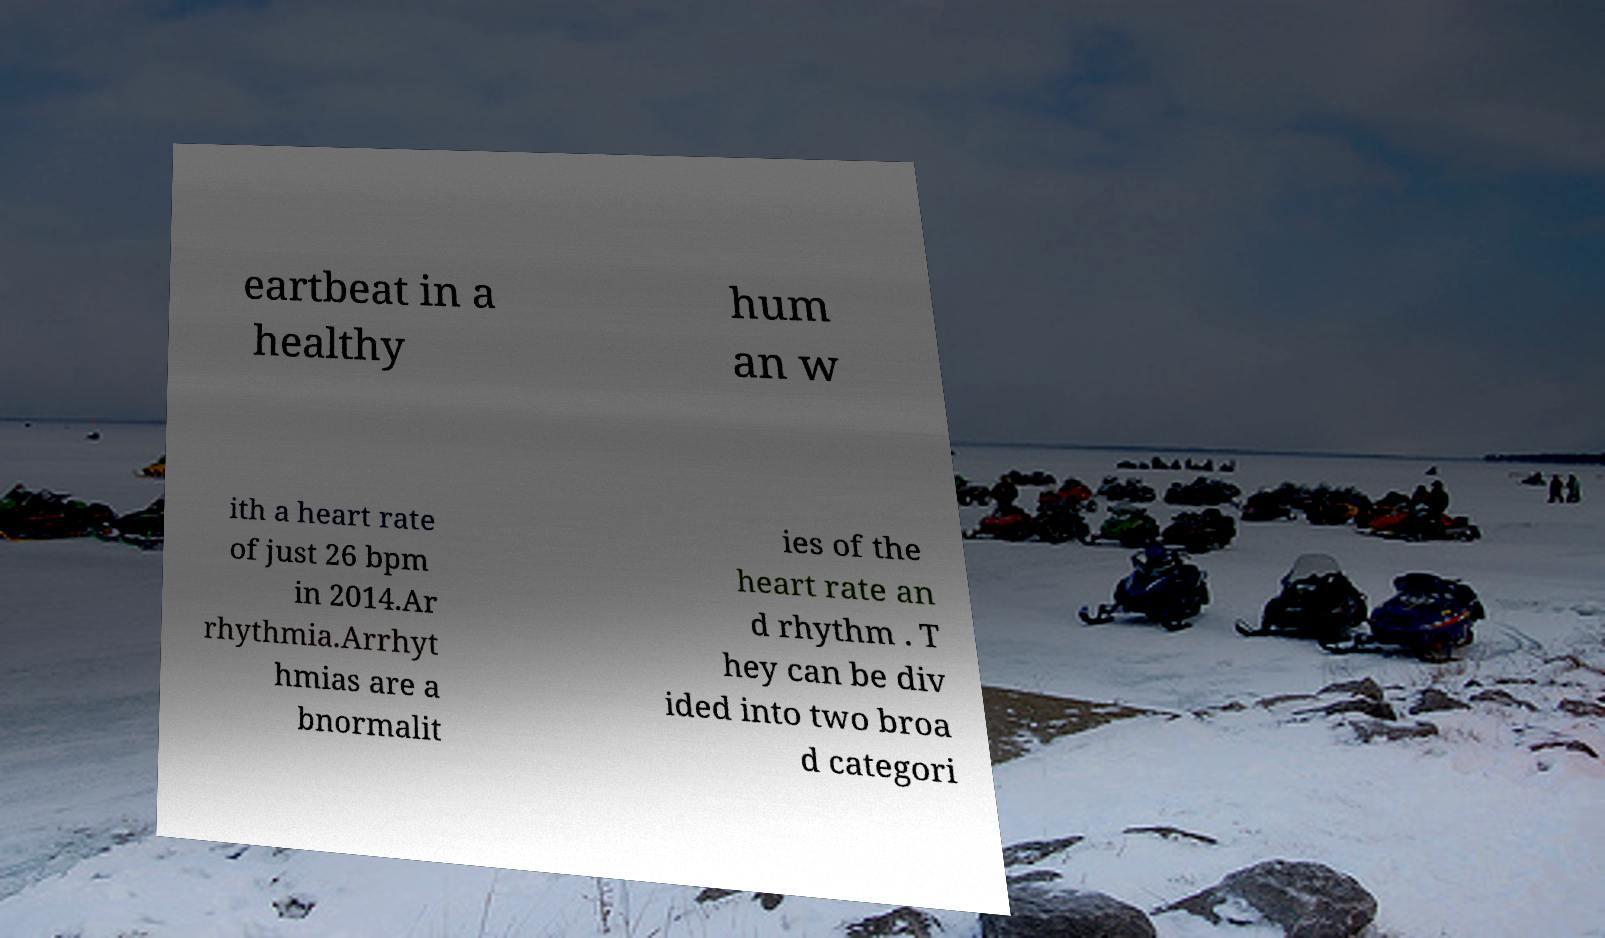Please read and relay the text visible in this image. What does it say? eartbeat in a healthy hum an w ith a heart rate of just 26 bpm in 2014.Ar rhythmia.Arrhyt hmias are a bnormalit ies of the heart rate an d rhythm . T hey can be div ided into two broa d categori 